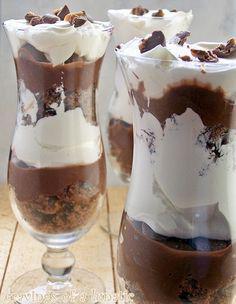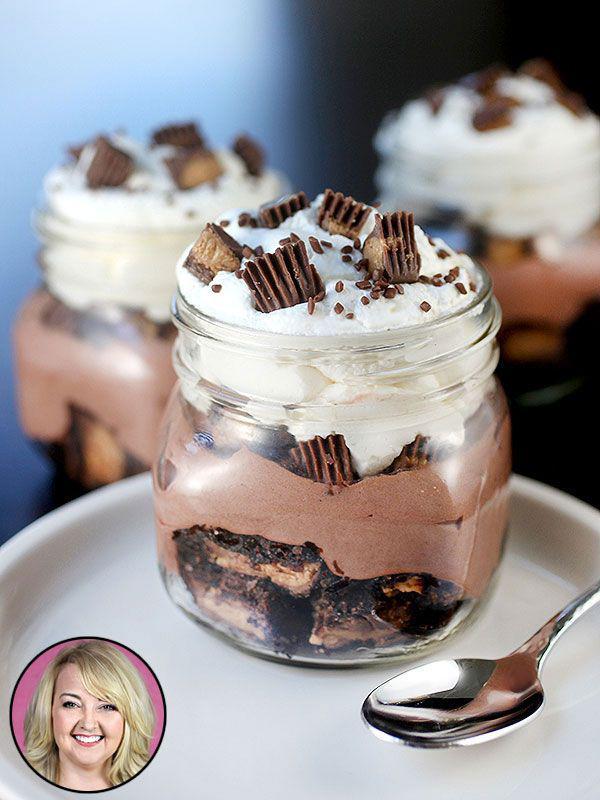The first image is the image on the left, the second image is the image on the right. For the images shown, is this caption "An image shows a cream-layered dessert in a clear footed glass." true? Answer yes or no. Yes. The first image is the image on the left, the second image is the image on the right. Considering the images on both sides, is "There are three silver spoons next to the desserts in one of the images." valid? Answer yes or no. No. 